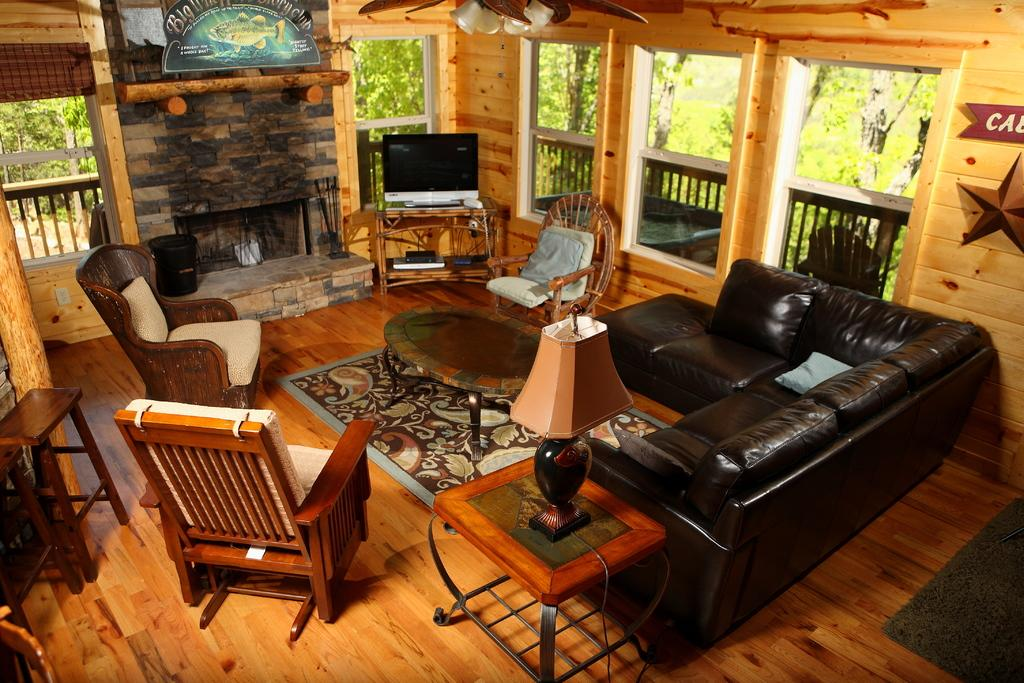What type of space is depicted in the image? There is a room in the image. What furniture is present in the room? The room contains a sofa, a fireplace, and a chair. Where is the window located in the room? There is a window on the left side of the room. What can be seen through the window? Trees are visible through the window. What is the floor made of in the room? The floor is made of wood. What type of writing can be seen on the wall in the image? There is no writing visible on the walls in the image. 